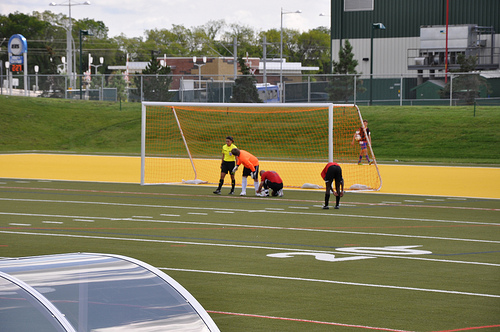<image>
Is there a person on the ground? Yes. Looking at the image, I can see the person is positioned on top of the ground, with the ground providing support. Is there a playground under the man? Yes. The playground is positioned underneath the man, with the man above it in the vertical space. 